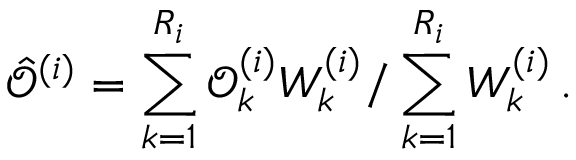<formula> <loc_0><loc_0><loc_500><loc_500>\hat { \mathcal { O } } ^ { ( i ) } = \sum _ { k = 1 } ^ { R _ { i } } \mathcal { O } _ { k } ^ { ( i ) } W _ { k } ^ { ( i ) } / \sum _ { k = 1 } ^ { R _ { i } } W _ { k } ^ { ( i ) } \, .</formula> 